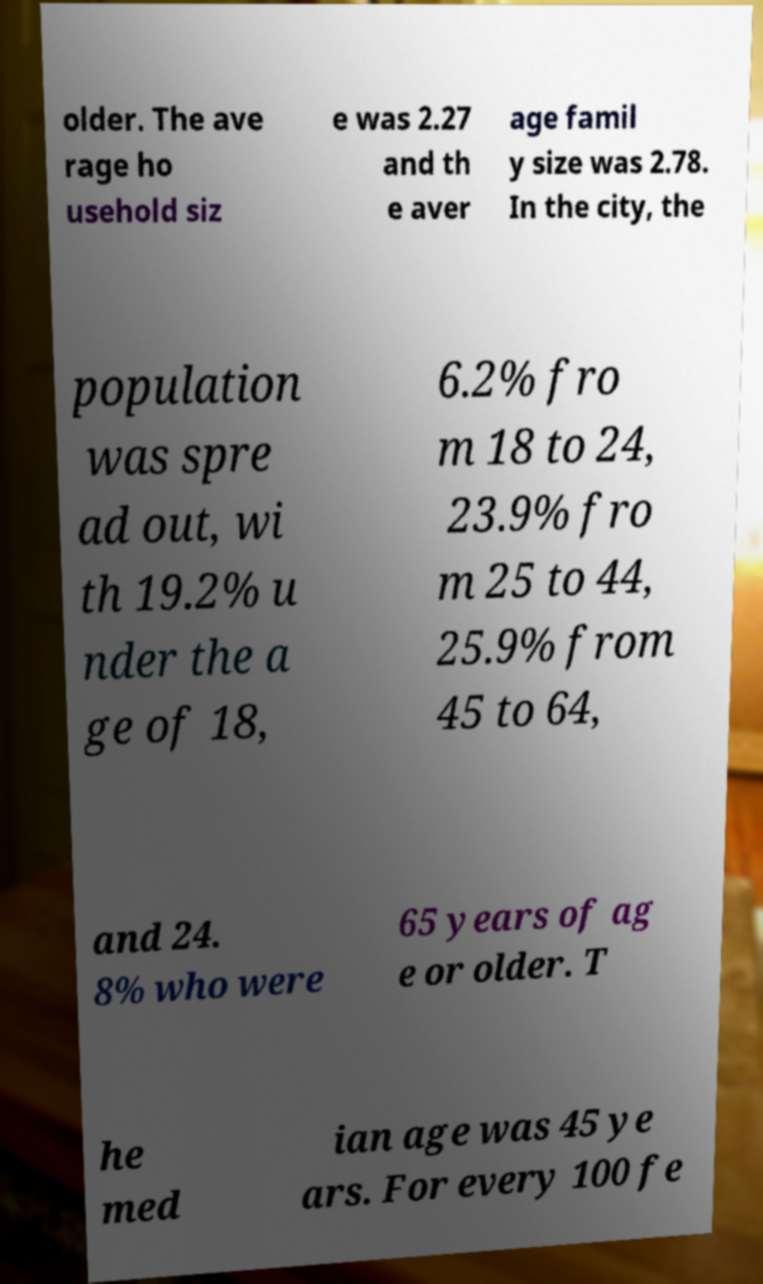Please identify and transcribe the text found in this image. older. The ave rage ho usehold siz e was 2.27 and th e aver age famil y size was 2.78. In the city, the population was spre ad out, wi th 19.2% u nder the a ge of 18, 6.2% fro m 18 to 24, 23.9% fro m 25 to 44, 25.9% from 45 to 64, and 24. 8% who were 65 years of ag e or older. T he med ian age was 45 ye ars. For every 100 fe 